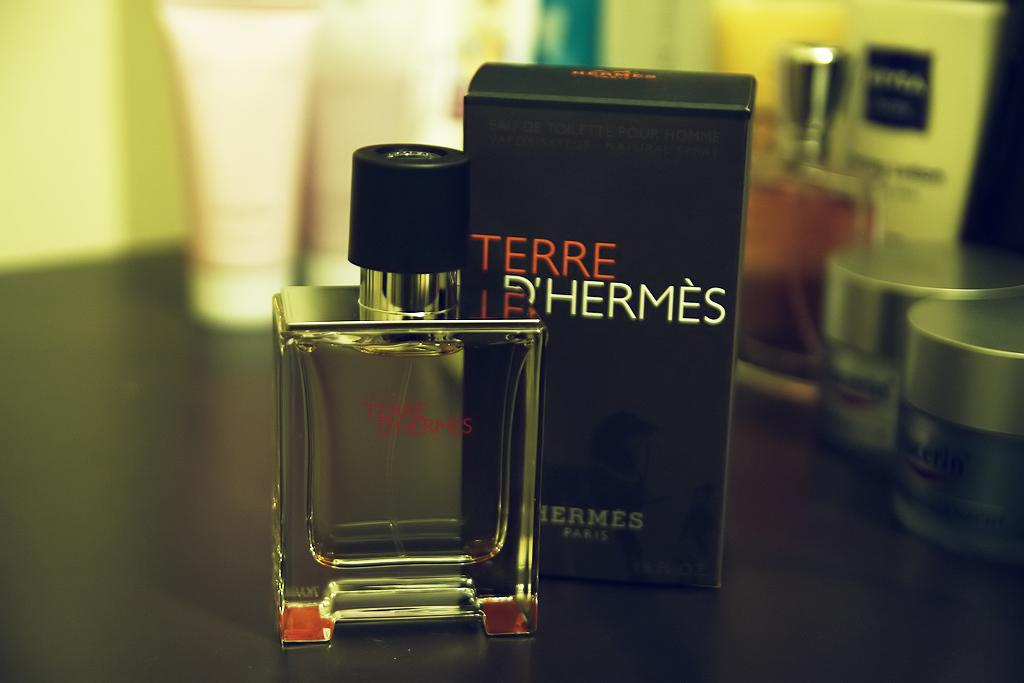<image>
Provide a brief description of the given image. A bottle of and box for Terr D'Hermes cologne. 